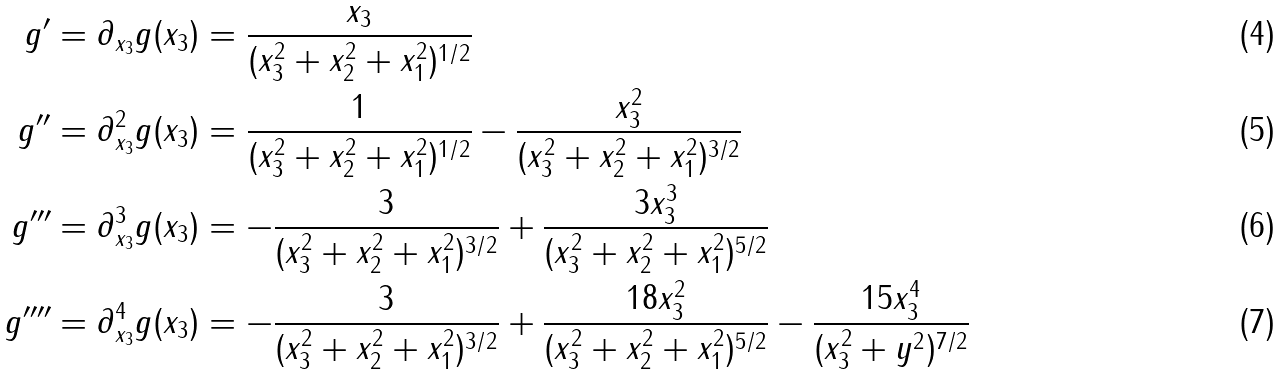<formula> <loc_0><loc_0><loc_500><loc_500>g ^ { \prime } = \partial _ { x _ { 3 } } g ( x _ { 3 } ) & = \frac { x _ { 3 } } { ( x _ { 3 } ^ { 2 } + x _ { 2 } ^ { 2 } + x _ { 1 } ^ { 2 } ) ^ { 1 / 2 } } \\ g ^ { \prime \prime } = \partial _ { x _ { 3 } } ^ { 2 } g ( x _ { 3 } ) & = \frac { 1 } { ( x _ { 3 } ^ { 2 } + x _ { 2 } ^ { 2 } + x _ { 1 } ^ { 2 } ) ^ { 1 / 2 } } - \frac { x _ { 3 } ^ { 2 } } { ( x _ { 3 } ^ { 2 } + x _ { 2 } ^ { 2 } + x _ { 1 } ^ { 2 } ) ^ { 3 / 2 } } \\ g ^ { \prime \prime \prime } = \partial _ { x _ { 3 } } ^ { 3 } g ( x _ { 3 } ) & = - \frac { 3 } { ( x _ { 3 } ^ { 2 } + x _ { 2 } ^ { 2 } + x _ { 1 } ^ { 2 } ) ^ { 3 / 2 } } + \frac { 3 x _ { 3 } ^ { 3 } } { ( x _ { 3 } ^ { 2 } + x _ { 2 } ^ { 2 } + x _ { 1 } ^ { 2 } ) ^ { 5 / 2 } } \\ g ^ { \prime \prime \prime \prime } = \partial _ { x _ { 3 } } ^ { 4 } g ( x _ { 3 } ) & = - \frac { 3 } { ( x _ { 3 } ^ { 2 } + x _ { 2 } ^ { 2 } + x _ { 1 } ^ { 2 } ) ^ { 3 / 2 } } + \frac { 1 8 x _ { 3 } ^ { 2 } } { ( x _ { 3 } ^ { 2 } + x _ { 2 } ^ { 2 } + x _ { 1 } ^ { 2 } ) ^ { 5 / 2 } } - \frac { 1 5 x _ { 3 } ^ { 4 } } { ( x _ { 3 } ^ { 2 } + y ^ { 2 } ) ^ { 7 / 2 } }</formula> 